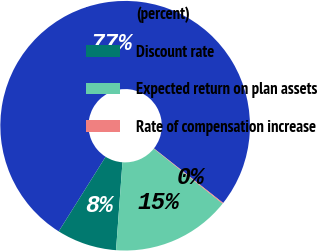Convert chart. <chart><loc_0><loc_0><loc_500><loc_500><pie_chart><fcel>(percent)<fcel>Discount rate<fcel>Expected return on plan assets<fcel>Rate of compensation increase<nl><fcel>76.7%<fcel>7.77%<fcel>15.43%<fcel>0.11%<nl></chart> 